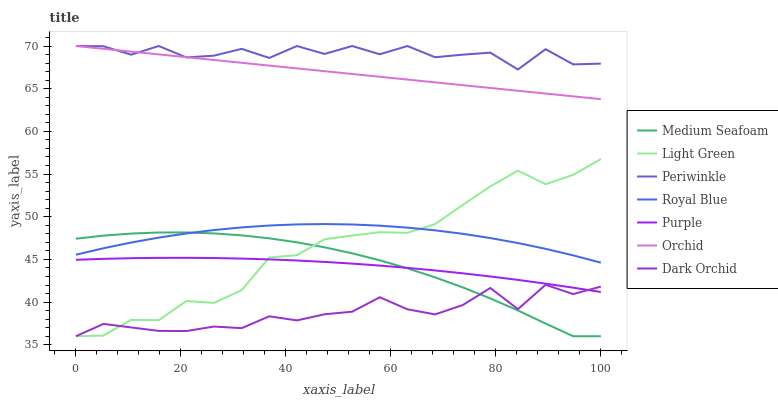Does Dark Orchid have the minimum area under the curve?
Answer yes or no. Yes. Does Periwinkle have the maximum area under the curve?
Answer yes or no. Yes. Does Royal Blue have the minimum area under the curve?
Answer yes or no. No. Does Royal Blue have the maximum area under the curve?
Answer yes or no. No. Is Orchid the smoothest?
Answer yes or no. Yes. Is Periwinkle the roughest?
Answer yes or no. Yes. Is Dark Orchid the smoothest?
Answer yes or no. No. Is Dark Orchid the roughest?
Answer yes or no. No. Does Royal Blue have the lowest value?
Answer yes or no. No. Does Orchid have the highest value?
Answer yes or no. Yes. Does Royal Blue have the highest value?
Answer yes or no. No. Is Medium Seafoam less than Periwinkle?
Answer yes or no. Yes. Is Periwinkle greater than Medium Seafoam?
Answer yes or no. Yes. Does Medium Seafoam intersect Purple?
Answer yes or no. Yes. Is Medium Seafoam less than Purple?
Answer yes or no. No. Is Medium Seafoam greater than Purple?
Answer yes or no. No. Does Medium Seafoam intersect Periwinkle?
Answer yes or no. No. 